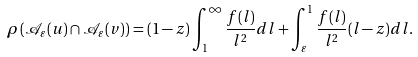Convert formula to latex. <formula><loc_0><loc_0><loc_500><loc_500>\rho \left ( \mathcal { A } _ { \varepsilon } ( u ) \cap \mathcal { A } _ { \varepsilon } ( v ) \right ) = ( 1 - z ) \int _ { 1 } ^ { \infty } \frac { f ( l ) } { l ^ { 2 } } d l + \int _ { \varepsilon } ^ { 1 } \frac { f ( l ) } { l ^ { 2 } } ( l - z ) d l .</formula> 